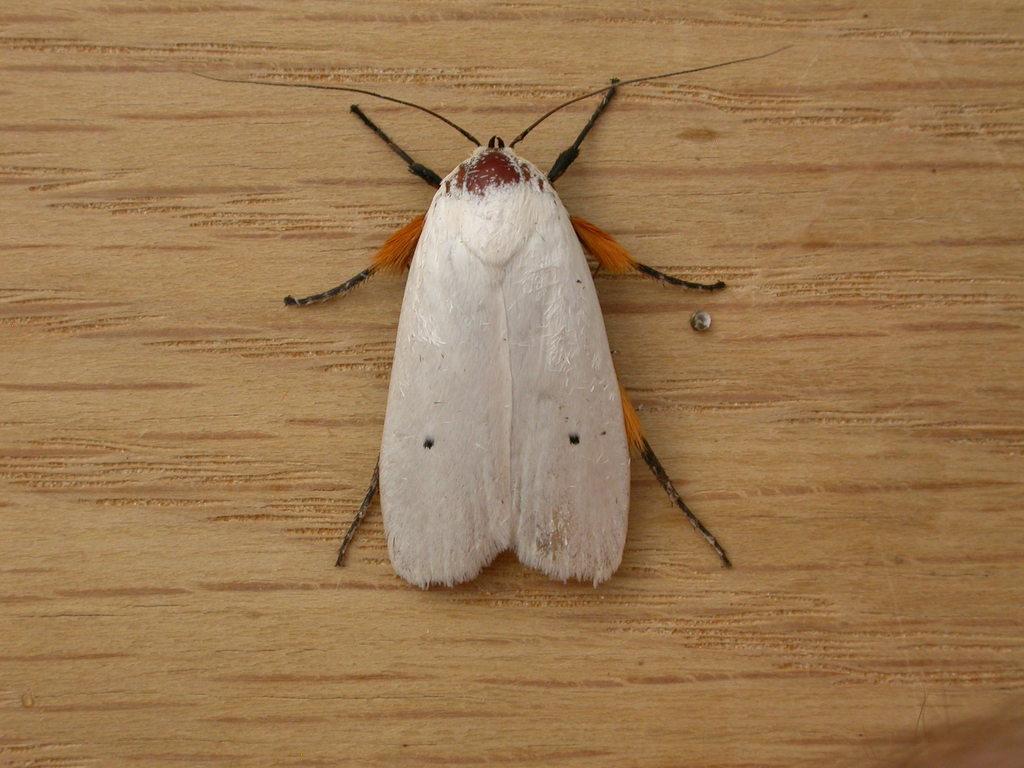Describe this image in one or two sentences. In this picture we can see an insect on a wooden surface. 